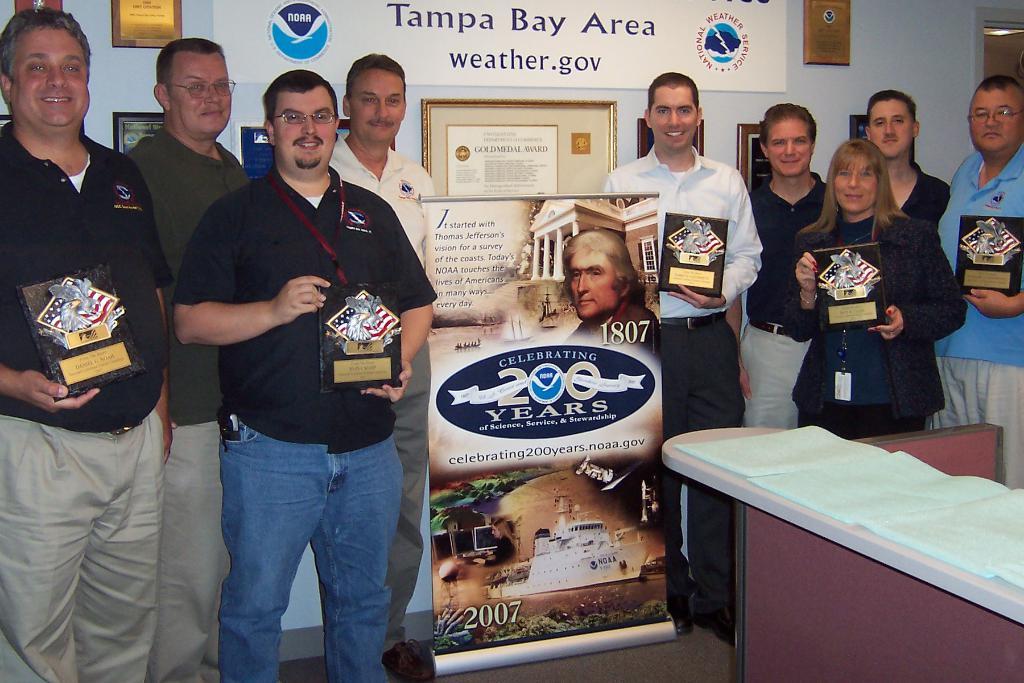What does the banner say?
Ensure brevity in your answer.  Celebrating 200 years. What year is on the banner?
Offer a terse response. 1807. 